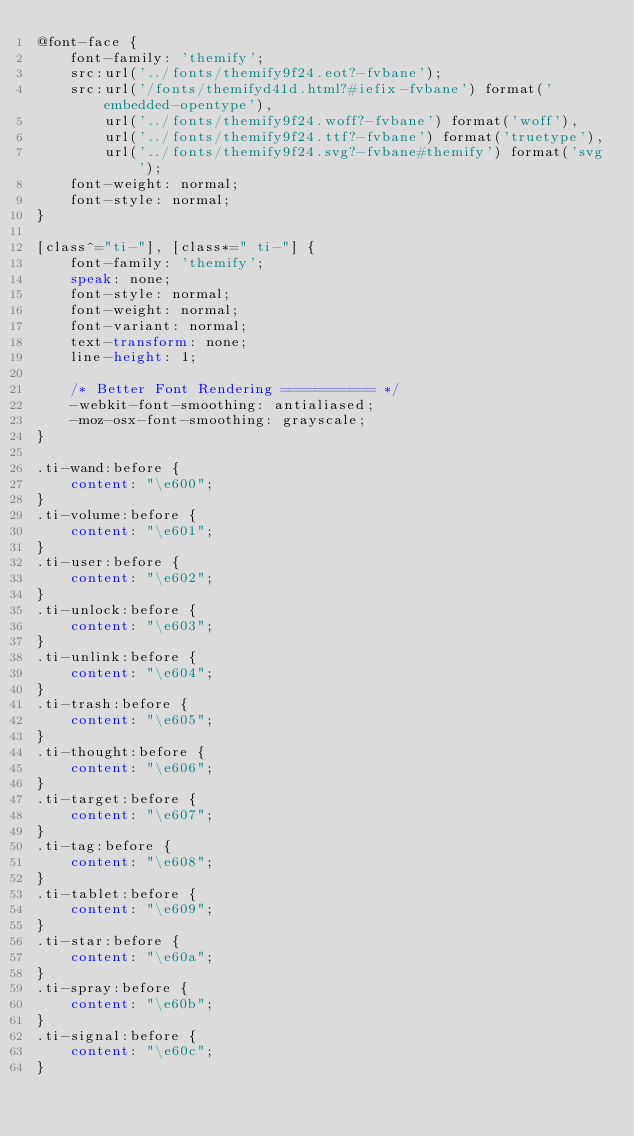Convert code to text. <code><loc_0><loc_0><loc_500><loc_500><_CSS_>@font-face {
	font-family: 'themify';
	src:url('../fonts/themify9f24.eot?-fvbane');
	src:url('/fonts/themifyd41d.html?#iefix-fvbane') format('embedded-opentype'),
		url('../fonts/themify9f24.woff?-fvbane') format('woff'),
		url('../fonts/themify9f24.ttf?-fvbane') format('truetype'),
		url('../fonts/themify9f24.svg?-fvbane#themify') format('svg');
	font-weight: normal;
	font-style: normal;
}

[class^="ti-"], [class*=" ti-"] {
	font-family: 'themify';
	speak: none;
	font-style: normal;
	font-weight: normal;
	font-variant: normal;
	text-transform: none;
	line-height: 1;

	/* Better Font Rendering =========== */
	-webkit-font-smoothing: antialiased;
	-moz-osx-font-smoothing: grayscale;
}

.ti-wand:before {
	content: "\e600";
}
.ti-volume:before {
	content: "\e601";
}
.ti-user:before {
	content: "\e602";
}
.ti-unlock:before {
	content: "\e603";
}
.ti-unlink:before {
	content: "\e604";
}
.ti-trash:before {
	content: "\e605";
}
.ti-thought:before {
	content: "\e606";
}
.ti-target:before {
	content: "\e607";
}
.ti-tag:before {
	content: "\e608";
}
.ti-tablet:before {
	content: "\e609";
}
.ti-star:before {
	content: "\e60a";
}
.ti-spray:before {
	content: "\e60b";
}
.ti-signal:before {
	content: "\e60c";
}</code> 